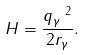<formula> <loc_0><loc_0><loc_500><loc_500>H = \frac { q _ { \gamma } ^ { \ 2 } } { 2 r _ { \gamma } } .</formula> 